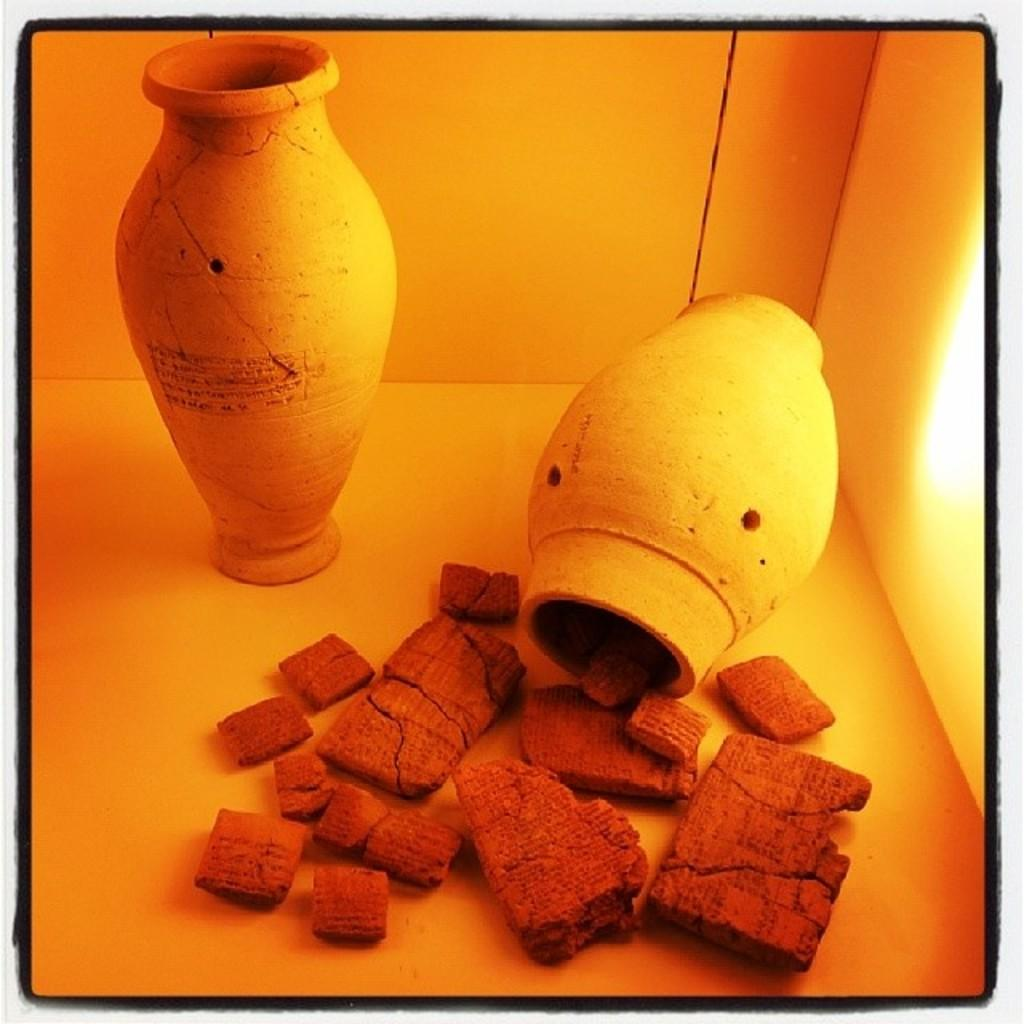What is placed in the center of the image? There are vases placed in the center of the image. On what surface are the vases placed? The vases are placed on a surface. What other objects can be seen in the image? There are bricks in the image. How many cakes are being shared by the geese in the image? There are no cakes or geese present in the image. What message of peace is being conveyed by the objects in the image? The image does not convey any specific message of peace; it simply shows vases placed on a surface and bricks. 